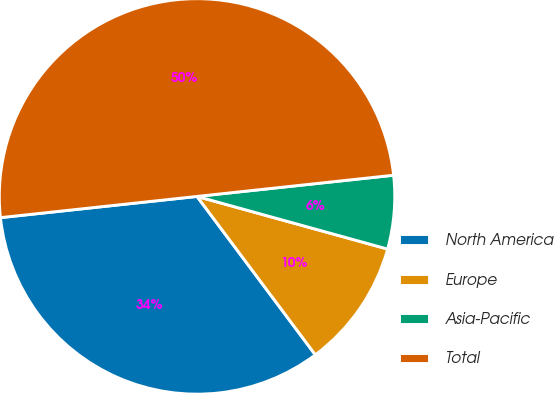Convert chart to OTSL. <chart><loc_0><loc_0><loc_500><loc_500><pie_chart><fcel>North America<fcel>Europe<fcel>Asia-Pacific<fcel>Total<nl><fcel>33.5%<fcel>10.5%<fcel>6.0%<fcel>50.0%<nl></chart> 